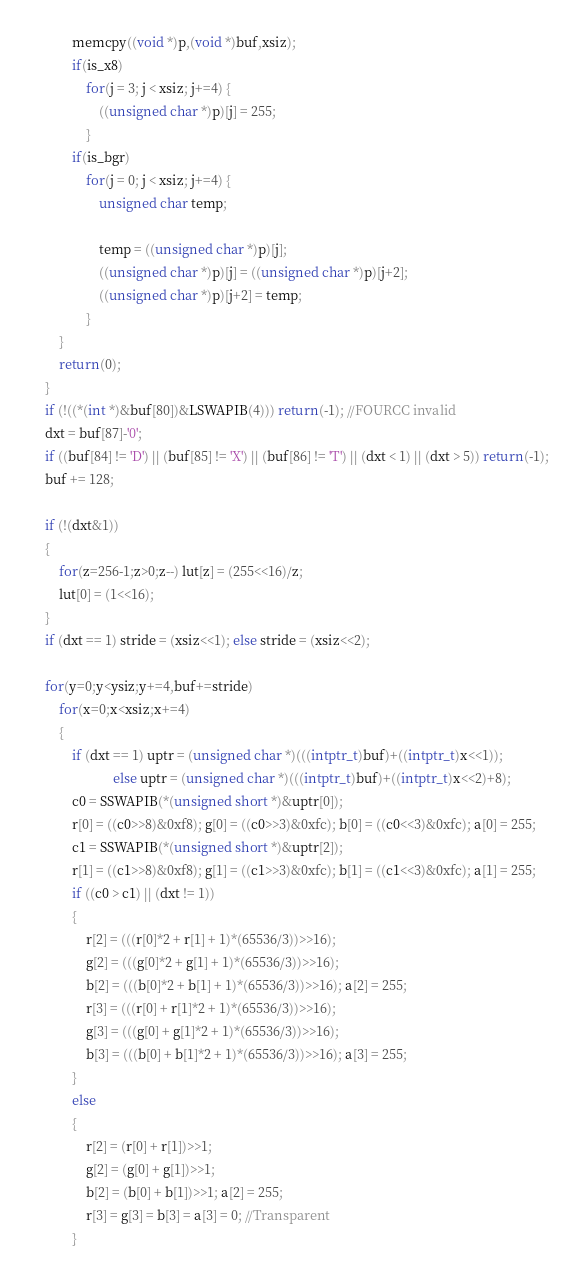<code> <loc_0><loc_0><loc_500><loc_500><_C_>			memcpy((void *)p,(void *)buf,xsiz);
			if(is_x8)
				for(j = 3; j < xsiz; j+=4) {
					((unsigned char *)p)[j] = 255;
				}
			if(is_bgr)
				for(j = 0; j < xsiz; j+=4) {
					unsigned char temp;
					
					temp = ((unsigned char *)p)[j];
					((unsigned char *)p)[j] = ((unsigned char *)p)[j+2];
					((unsigned char *)p)[j+2] = temp;
				}
		}
		return(0);
	}
	if (!((*(int *)&buf[80])&LSWAPIB(4))) return(-1); //FOURCC invalid
	dxt = buf[87]-'0';
	if ((buf[84] != 'D') || (buf[85] != 'X') || (buf[86] != 'T') || (dxt < 1) || (dxt > 5)) return(-1);
	buf += 128;

	if (!(dxt&1))
	{
		for(z=256-1;z>0;z--) lut[z] = (255<<16)/z;
		lut[0] = (1<<16);
	}
	if (dxt == 1) stride = (xsiz<<1); else stride = (xsiz<<2);

	for(y=0;y<ysiz;y+=4,buf+=stride)
		for(x=0;x<xsiz;x+=4)
		{
			if (dxt == 1) uptr = (unsigned char *)(((intptr_t)buf)+((intptr_t)x<<1));
						else uptr = (unsigned char *)(((intptr_t)buf)+((intptr_t)x<<2)+8);
			c0 = SSWAPIB(*(unsigned short *)&uptr[0]);
			r[0] = ((c0>>8)&0xf8); g[0] = ((c0>>3)&0xfc); b[0] = ((c0<<3)&0xfc); a[0] = 255;
			c1 = SSWAPIB(*(unsigned short *)&uptr[2]);
			r[1] = ((c1>>8)&0xf8); g[1] = ((c1>>3)&0xfc); b[1] = ((c1<<3)&0xfc); a[1] = 255;
			if ((c0 > c1) || (dxt != 1))
			{
				r[2] = (((r[0]*2 + r[1] + 1)*(65536/3))>>16);
				g[2] = (((g[0]*2 + g[1] + 1)*(65536/3))>>16);
				b[2] = (((b[0]*2 + b[1] + 1)*(65536/3))>>16); a[2] = 255;
				r[3] = (((r[0] + r[1]*2 + 1)*(65536/3))>>16);
				g[3] = (((g[0] + g[1]*2 + 1)*(65536/3))>>16);
				b[3] = (((b[0] + b[1]*2 + 1)*(65536/3))>>16); a[3] = 255;
			}
			else
			{
				r[2] = (r[0] + r[1])>>1;
				g[2] = (g[0] + g[1])>>1;
				b[2] = (b[0] + b[1])>>1; a[2] = 255;
				r[3] = g[3] = b[3] = a[3] = 0; //Transparent
			}</code> 